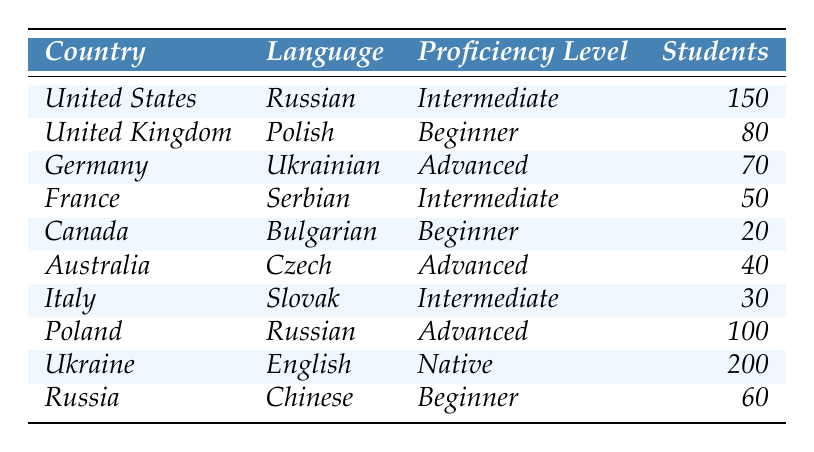What country has the most students proficient in English? The table lists Ukraine with 200 students confirmed to have native proficiency in English, which is the highest number among all countries for the languages listed.
Answer: Ukraine Which language is spoken by students in Canada, and what is their proficiency level? The table shows that students in Canada are learning Bulgarian, and their proficiency level is classified as Beginner.
Answer: Bulgarian, Beginner How many students are classified at the Advanced proficiency level? The table provides the number of students at the Advanced level: 70 from Germany (Ukrainian) and 100 from Poland (Russian), totaling 170 students.
Answer: 170 Is there a country where students are beginners in both Russian and Polish? The table indicates that Russia has 60 students who are Beginners in Chinese, and the United Kingdom has 80 students at a Beginner level in Polish. However, there is no mention of students from either country learning Russian as Beginners.
Answer: No Which country has the highest number of students enrolled in Russian language classes? Upon examining the table, Poland has 100 students studying Russian compared to 150 students in the United States who are at Intermediate proficiency, thus making Poland the country producing the highest total among those listed.
Answer: Poland What is the total number of students learning Slavic languages from all countries? To find this total, we add up the students from each row related to Slavic languages: Russian (150 from the United States, 100 from Poland), Polish (80 from the United Kingdom), Ukrainian (70 from Germany), Serbian (50 from France), Bulgarian (20 from Canada), Czech (40 from Australia), and Slovak (30 from Italy). The total is 150 + 100 + 80 + 70 + 50 + 20 + 40 + 30 = 540.
Answer: 540 Which language has the least number of students enrolled at the Beginner level? Looking through the Beginner level column, there are 20 students studying Bulgarian in Canada, which is the lowest number listed, while Russian from Russia has 60 students.
Answer: Bulgarian Is there a country where students are classified at the Intermediate level, and how many are there? The table reveals that students from the United States (150), France (50), and Italy (30) are classified at the Intermediate level, totaling 230 students in these three countries.
Answer: 230 How many countries have learners with Advanced proficiency? The table shows two countries, Germany and Poland, with a total of three languages listed at the Advanced proficiency level. So, the answer is two countries.
Answer: 2 What is the proficiency level of students in Australia? The table states that students in Australia are studying Czech and their proficiency level is noted as Advanced.
Answer: Advanced From which country do students have the Native proficiency level, and how many are there? The table indicates that students from Ukraine have Native proficiency in English, with a total of 200 students reported in that category.
Answer: Ukraine, 200 